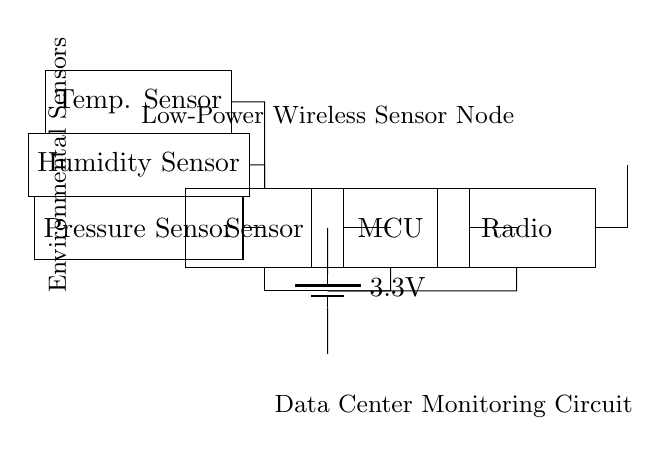What is the voltage supply for the circuit? The circuit specifies a battery with a labeling of 3.3V, indicating the voltage supply connected to the components.
Answer: 3.3V What type of sensors are present in the circuit? The circuit includes temperature, humidity, and pressure sensors, which are visible in the components section with their corresponding labels.
Answer: Temperature, humidity, pressure What type of communication module is used in this circuit? The circuit indicates a radio module, which is used for wireless communication, as inferred from the labeled component in the diagram.
Answer: Radio How many sensors are connected to the sensor node? The diagram shows three sensor components connected to the sensor node, specifically the temperature, humidity, and pressure sensors.
Answer: Three What is the purpose of the antenna in the circuit? The antenna is attached to the radio component and is designed for transmitting and receiving wireless signals, which is essential for a wireless sensor network.
Answer: Wireless communication What devices are powered by the battery in the circuit? The schematic shows that the sensor, microcontroller unit, and radio module are all connected to the power supply, indicating that they are powered by the battery.
Answer: Sensor, MCU, radio How does the data from the sensors reach the monitoring section? The data from the sensors flows to the sensor node, which is then connected to the microcontroller and subsequently to the radio for transmission, creating a path for data communication.
Answer: Through the sensor node and radio 